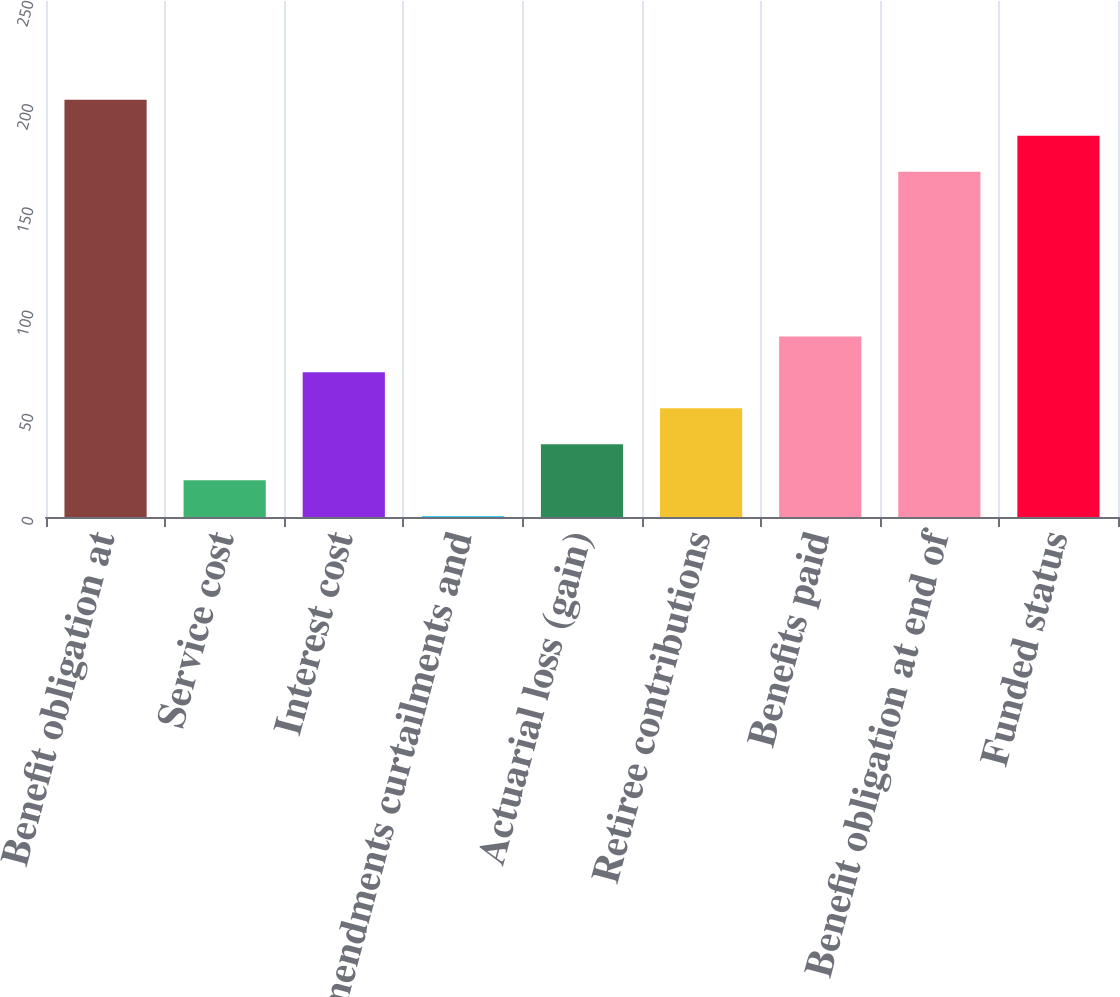Convert chart to OTSL. <chart><loc_0><loc_0><loc_500><loc_500><bar_chart><fcel>Benefit obligation at<fcel>Service cost<fcel>Interest cost<fcel>Amendments curtailments and<fcel>Actuarial loss (gain)<fcel>Retiree contributions<fcel>Benefits paid<fcel>Benefit obligation at end of<fcel>Funded status<nl><fcel>202.14<fcel>17.82<fcel>70.08<fcel>0.4<fcel>35.24<fcel>52.66<fcel>87.5<fcel>167.3<fcel>184.72<nl></chart> 